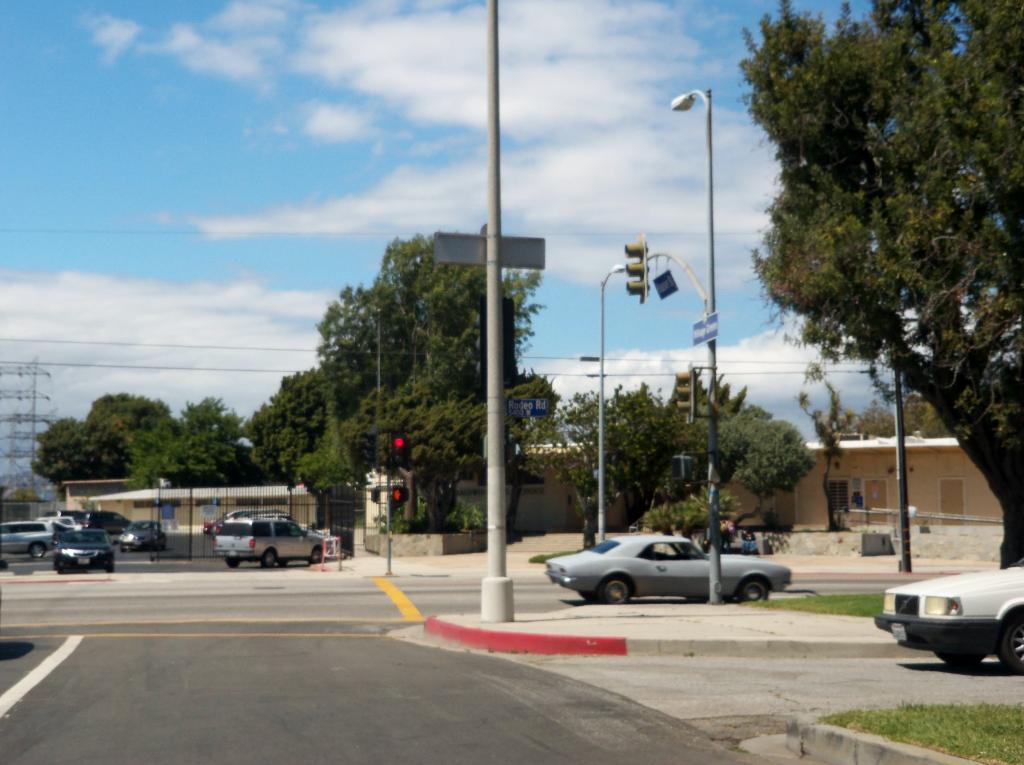Can you describe this image briefly? In this picture we can see there are vehicles on the roads. On the right side of the road, those are looking like houses and there are poles with traffic signals and a light. Behind the vehicles, there are trees and the sky. 